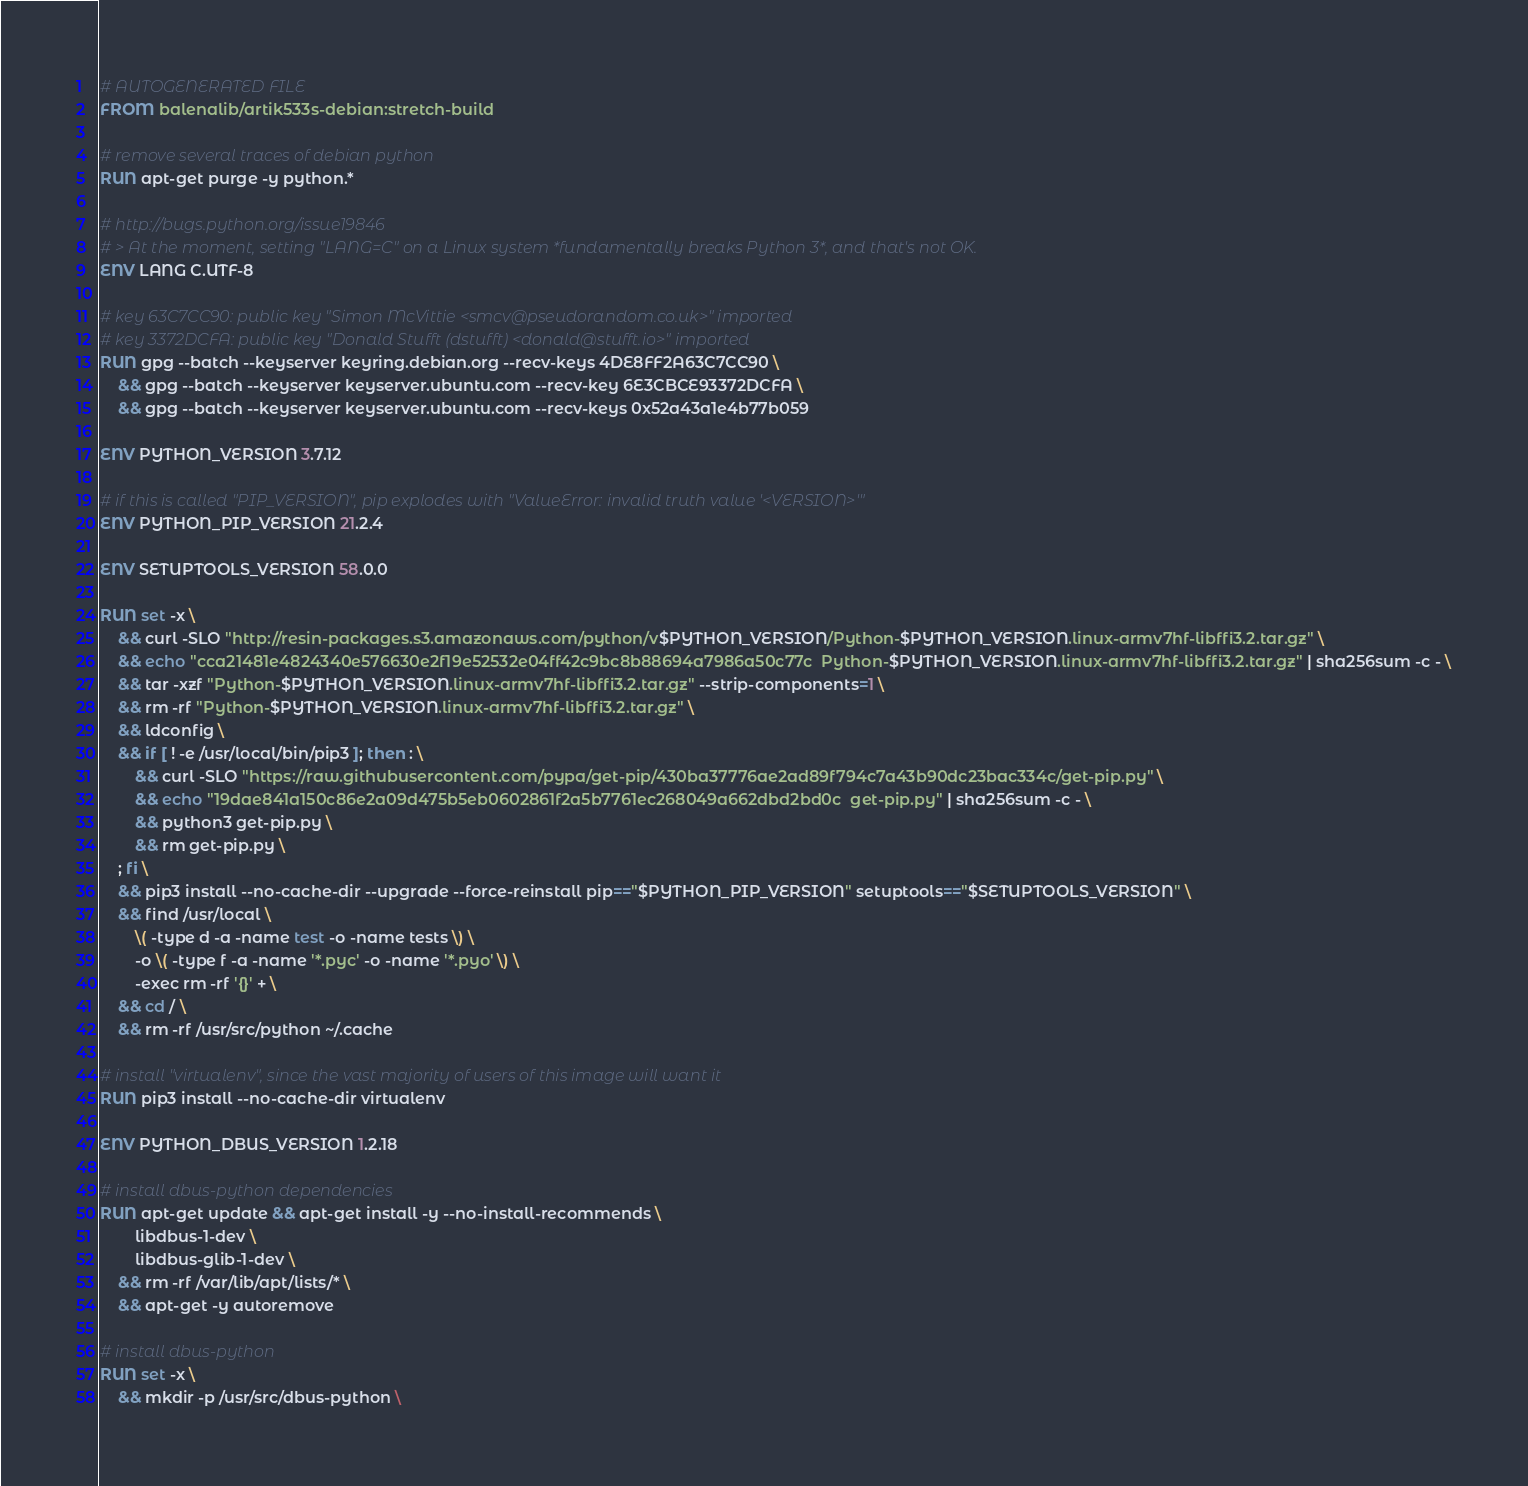<code> <loc_0><loc_0><loc_500><loc_500><_Dockerfile_># AUTOGENERATED FILE
FROM balenalib/artik533s-debian:stretch-build

# remove several traces of debian python
RUN apt-get purge -y python.*

# http://bugs.python.org/issue19846
# > At the moment, setting "LANG=C" on a Linux system *fundamentally breaks Python 3*, and that's not OK.
ENV LANG C.UTF-8

# key 63C7CC90: public key "Simon McVittie <smcv@pseudorandom.co.uk>" imported
# key 3372DCFA: public key "Donald Stufft (dstufft) <donald@stufft.io>" imported
RUN gpg --batch --keyserver keyring.debian.org --recv-keys 4DE8FF2A63C7CC90 \
	&& gpg --batch --keyserver keyserver.ubuntu.com --recv-key 6E3CBCE93372DCFA \
	&& gpg --batch --keyserver keyserver.ubuntu.com --recv-keys 0x52a43a1e4b77b059

ENV PYTHON_VERSION 3.7.12

# if this is called "PIP_VERSION", pip explodes with "ValueError: invalid truth value '<VERSION>'"
ENV PYTHON_PIP_VERSION 21.2.4

ENV SETUPTOOLS_VERSION 58.0.0

RUN set -x \
	&& curl -SLO "http://resin-packages.s3.amazonaws.com/python/v$PYTHON_VERSION/Python-$PYTHON_VERSION.linux-armv7hf-libffi3.2.tar.gz" \
	&& echo "cca21481e4824340e576630e2f19e52532e04ff42c9bc8b88694a7986a50c77c  Python-$PYTHON_VERSION.linux-armv7hf-libffi3.2.tar.gz" | sha256sum -c - \
	&& tar -xzf "Python-$PYTHON_VERSION.linux-armv7hf-libffi3.2.tar.gz" --strip-components=1 \
	&& rm -rf "Python-$PYTHON_VERSION.linux-armv7hf-libffi3.2.tar.gz" \
	&& ldconfig \
	&& if [ ! -e /usr/local/bin/pip3 ]; then : \
		&& curl -SLO "https://raw.githubusercontent.com/pypa/get-pip/430ba37776ae2ad89f794c7a43b90dc23bac334c/get-pip.py" \
		&& echo "19dae841a150c86e2a09d475b5eb0602861f2a5b7761ec268049a662dbd2bd0c  get-pip.py" | sha256sum -c - \
		&& python3 get-pip.py \
		&& rm get-pip.py \
	; fi \
	&& pip3 install --no-cache-dir --upgrade --force-reinstall pip=="$PYTHON_PIP_VERSION" setuptools=="$SETUPTOOLS_VERSION" \
	&& find /usr/local \
		\( -type d -a -name test -o -name tests \) \
		-o \( -type f -a -name '*.pyc' -o -name '*.pyo' \) \
		-exec rm -rf '{}' + \
	&& cd / \
	&& rm -rf /usr/src/python ~/.cache

# install "virtualenv", since the vast majority of users of this image will want it
RUN pip3 install --no-cache-dir virtualenv

ENV PYTHON_DBUS_VERSION 1.2.18

# install dbus-python dependencies 
RUN apt-get update && apt-get install -y --no-install-recommends \
		libdbus-1-dev \
		libdbus-glib-1-dev \
	&& rm -rf /var/lib/apt/lists/* \
	&& apt-get -y autoremove

# install dbus-python
RUN set -x \
	&& mkdir -p /usr/src/dbus-python \</code> 